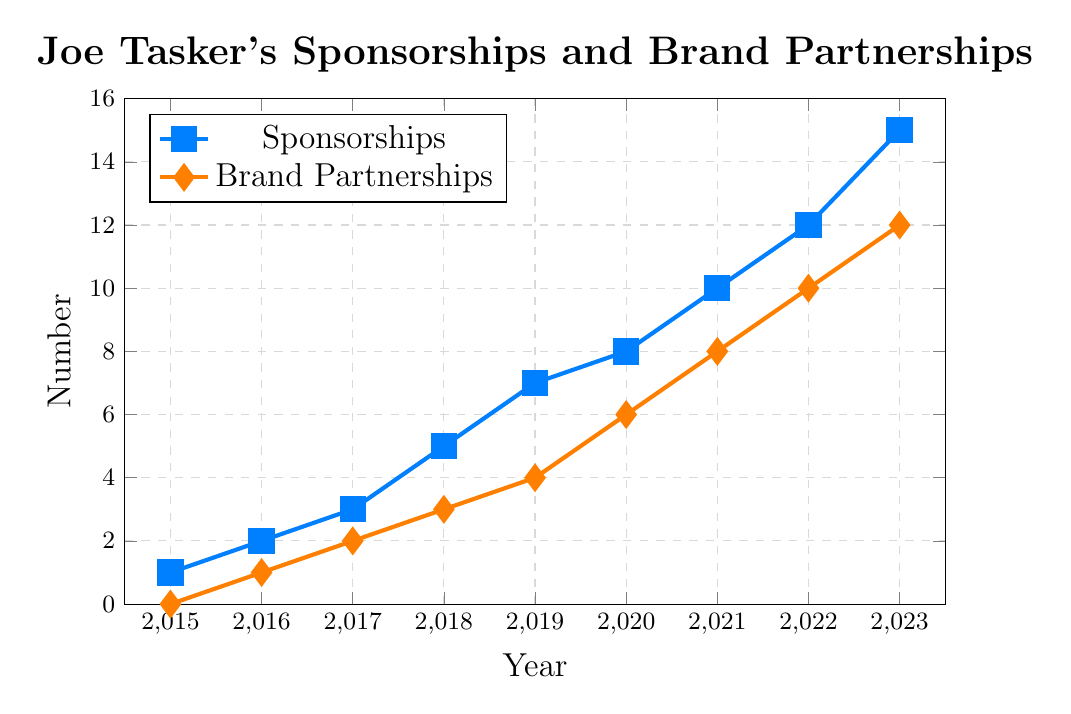What's the total number of sponsorships and brand partnerships in 2020? To find the total, sum the number of sponsorships and brand partnerships for the year 2020. Based on the figure, there are 8 sponsorships and 6 brand partnerships. The total is 8 + 6 = 14
Answer: 14 Which year saw the highest increase in sponsorships? To determine this, look at the differences in the number of sponsorships year-over-year. From the figure:
2015 to 2016: 2 - 1 = 1
2016 to 2017: 3 - 2 = 1
2017 to 2018: 5 - 3 = 2
2018 to 2019: 7 - 5 = 2
2019 to 2020: 8 - 7 = 1
2020 to 2021: 10 - 8 = 2
2021 to 2022: 12 - 10 = 2
2022 to 2023: 15 - 12 = 3
Therefore, the highest increase is 3 (from 2022 to 2023)
Answer: 2022 to 2023 In what year do the sponsorship deals start to surpass 10? According to the figure, the number of sponsorship deals reaches 10 in 2021. Therefore, the year sponsorship deals start to surpass 10 is 2022
Answer: 2022 Compare the number of brand partnerships in 2017 and 2023. From the figure, in 2017 there are 2 brand partnerships, and in 2023 there are 12 brand partnerships. Comparing these, 12 is greater than 2
Answer: More in 2023 What is the average number of sponsorships from 2015 to 2018? To calculate the average number of sponsorships from 2015 to 2018, sum the values for these years and divide by the number of years:
(1 + 2 + 3 + 5) / 4 = 11 / 4 = 2.75
Answer: 2.75 How many sponsorships and brand partnerships are there altogether from 2021 to 2023? Sum the number of sponsorships and brand partnerships separately from 2021 to 2023, then add the totals:
Sponsorships: 10 + 12 + 15 = 37
Brand Partnerships: 8 + 10 + 12 = 30
Total: 37 + 30 = 67
Answer: 67 In which year is the gap between sponsorships and brand partnerships the greatest? Calculate the difference between sponsorships and brand partnerships for each year:
2015: 1 - 0 = 1
2016: 2 - 1 = 1
2017: 3 - 2 = 1
2018: 5 - 3 = 2
2019: 7 - 4 = 3
2020: 8 - 6 = 2
2021: 10 - 8 = 2
2022: 12 - 10 = 2
2023: 15 - 12 = 3
The greatest gap is 3 (in 2019 and 2023)
Answer: 2019 and 2023 What color represents brand partnerships in the figure? Look at the legend in the figure. The line representing brand partnerships is shown in orange.
Answer: Orange Between which consecutive years did brand partnerships grow the most? Determine the differences in brand partnerships year-over-year:
2015 to 2016: 1 - 0 = 1
2016 to 2017: 2 - 1 = 1
2017 to 2018: 3 - 2 = 1
2018 to 2019: 4 - 3 = 1
2019 to 2020: 6 - 4 = 2
2020 to 2021: 8 - 6 = 2
2021 to 2022: 10 - 8 = 2
2022 to 2023: 12 - 10 = 2
The highest growth is 2, occurring between 2019 to 2020, 2020 to 2021, 2021 to 2022, and 2022 to 2023.
Answer: 2019 to 2020; 2020 to 2021; 2021 to 2022; 2022 to 2023 